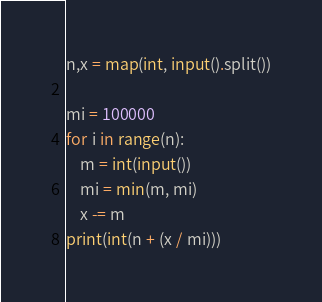Convert code to text. <code><loc_0><loc_0><loc_500><loc_500><_Python_>n,x = map(int, input().split())

mi = 100000
for i in range(n):
    m = int(input())
    mi = min(m, mi)
    x -= m
print(int(n + (x / mi)))</code> 